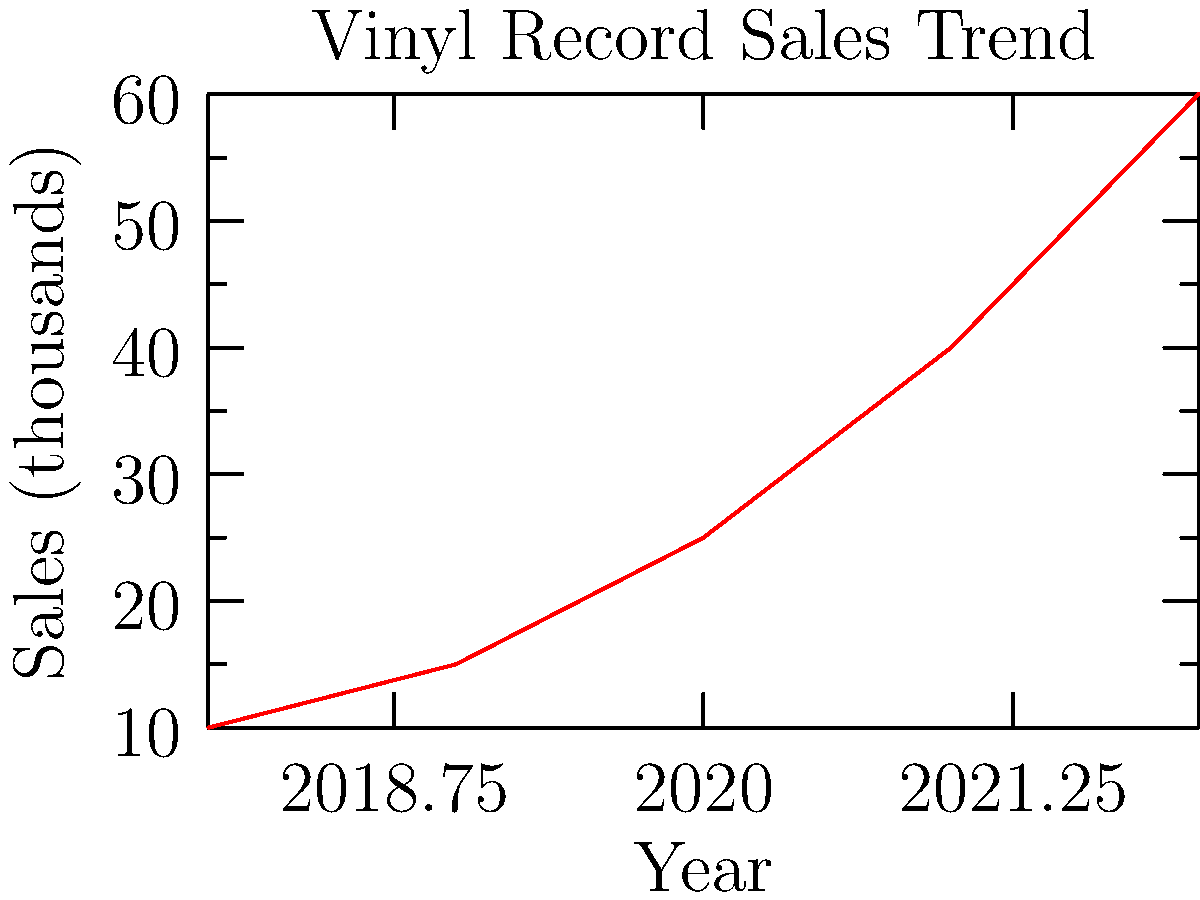Based on the graph showing vinyl record sales trends over the past 5 years, which machine learning model would be most appropriate for predicting future sales, and why? To determine the most appropriate machine learning model for predicting future vinyl record sales, we need to analyze the trend in the given graph:

1. Observe the data: The graph shows a clear upward trend in vinyl record sales from 2018 to 2022.

2. Identify the pattern: The increase appears to be non-linear, with the rate of growth accelerating over time.

3. Consider the data type: We have a time series data set with a single variable (sales) changing over time.

4. Evaluate model options:
   a) Linear Regression: Not ideal as the trend is non-linear.
   b) Polynomial Regression: Could capture the non-linear trend but may overfit.
   c) Time Series Models (e.g., ARIMA): Good for capturing trends and seasonality in time series data.
   d) Exponential Smoothing: Suitable for data with clear trends and no seasonality.

5. Choose the best model: Given the clear non-linear trend without apparent seasonality, exponential smoothing would be an appropriate choice. It can capture the accelerating growth pattern and is less prone to overfitting compared to polynomial regression.

6. Justification: Exponential smoothing models are particularly good at forecasting data with clear trends. They give more weight to recent observations, which is beneficial in this case as the growth rate is increasing in recent years.
Answer: Exponential smoothing 